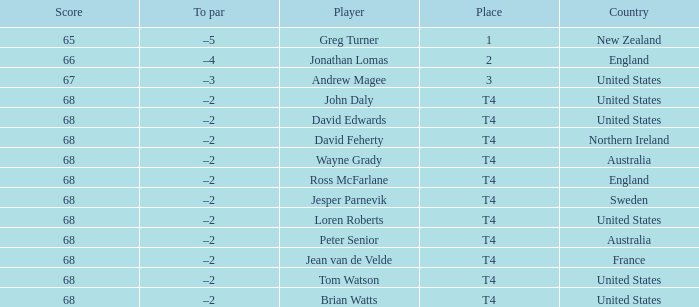Name the Score united states of tom watson in united state? 68.0. 